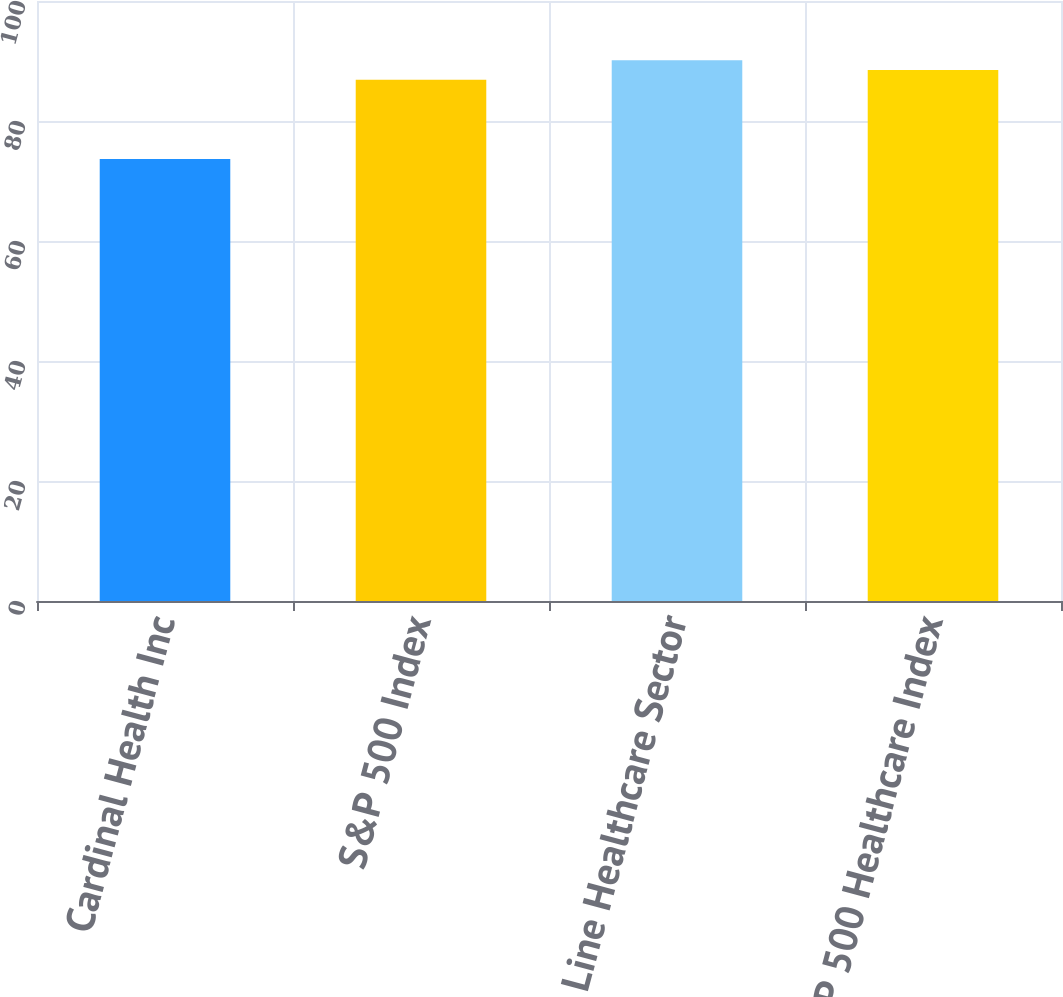Convert chart. <chart><loc_0><loc_0><loc_500><loc_500><bar_chart><fcel>Cardinal Health Inc<fcel>S&P 500 Index<fcel>Value Line Healthcare Sector<fcel>S&P 500 Healthcare Index<nl><fcel>73.68<fcel>86.88<fcel>90.12<fcel>88.5<nl></chart> 